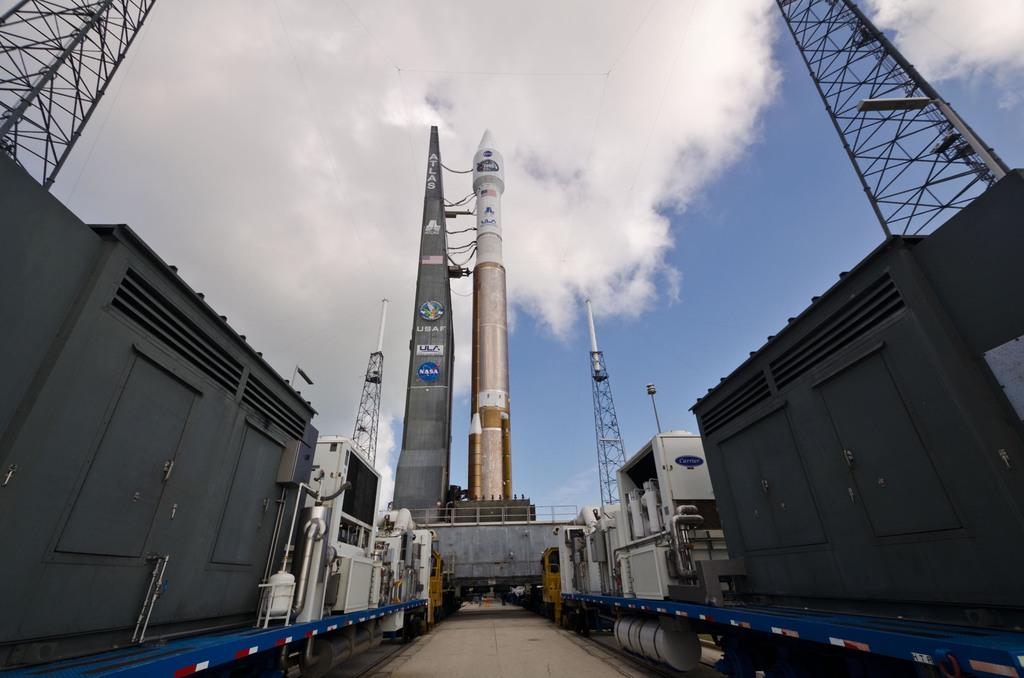What types of objects can be seen in the image? There are containers, towers, and a rocket in the image. Can you describe the object in the image? There is an object in the image, but its specific details are not mentioned in the facts. What is visible on the ground in the image? The ground is visible in the image. What is visible in the sky in the image? The sky is visible in the image, and clouds are present in the sky. How many bears can be seen playing with bikes in the image? There are no bears or bikes present in the image. 